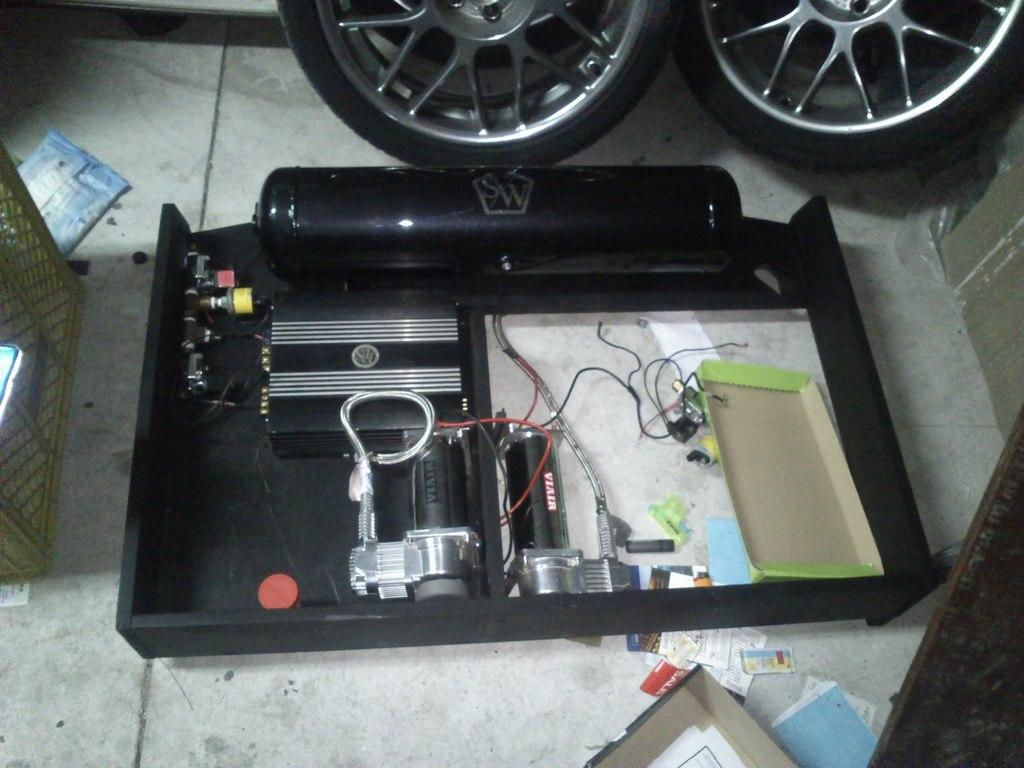What is the main subject in the center of the image? There is an electrical equipment in the center of the image. What can be seen on the left side of the image? There is a basket on the left side of the image. What is placed on the floor in the image? There are things placed on the floor in the image. Can you see a squirrel playing volleyball with a tramp in the image? No, there is no squirrel, volleyball, or tramp present in the image. 